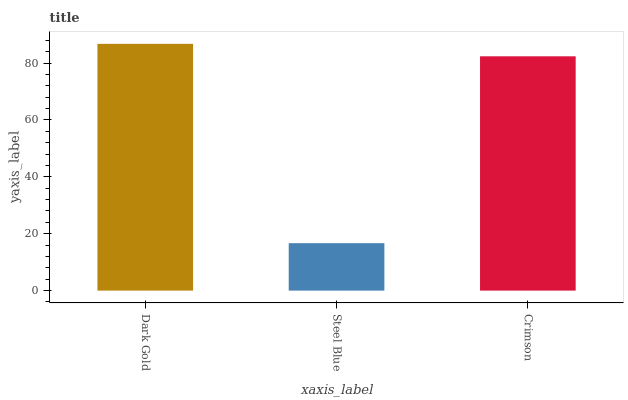Is Crimson the minimum?
Answer yes or no. No. Is Crimson the maximum?
Answer yes or no. No. Is Crimson greater than Steel Blue?
Answer yes or no. Yes. Is Steel Blue less than Crimson?
Answer yes or no. Yes. Is Steel Blue greater than Crimson?
Answer yes or no. No. Is Crimson less than Steel Blue?
Answer yes or no. No. Is Crimson the high median?
Answer yes or no. Yes. Is Crimson the low median?
Answer yes or no. Yes. Is Dark Gold the high median?
Answer yes or no. No. Is Steel Blue the low median?
Answer yes or no. No. 